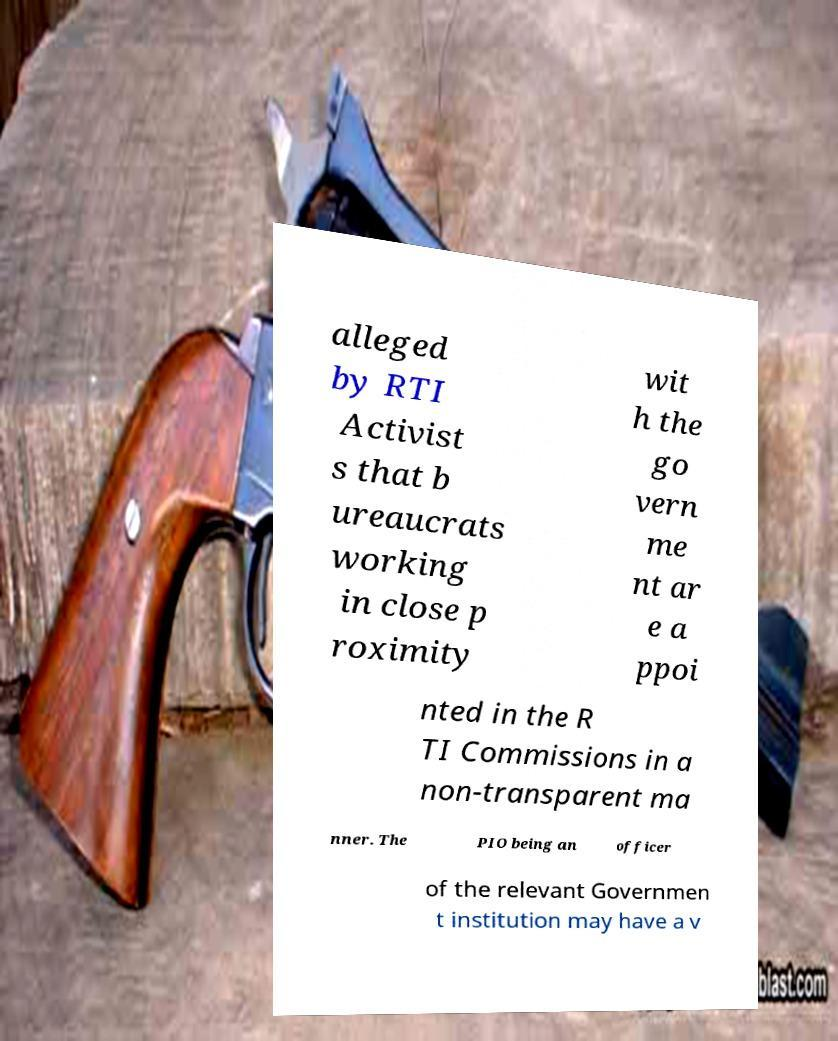There's text embedded in this image that I need extracted. Can you transcribe it verbatim? alleged by RTI Activist s that b ureaucrats working in close p roximity wit h the go vern me nt ar e a ppoi nted in the R TI Commissions in a non-transparent ma nner. The PIO being an officer of the relevant Governmen t institution may have a v 